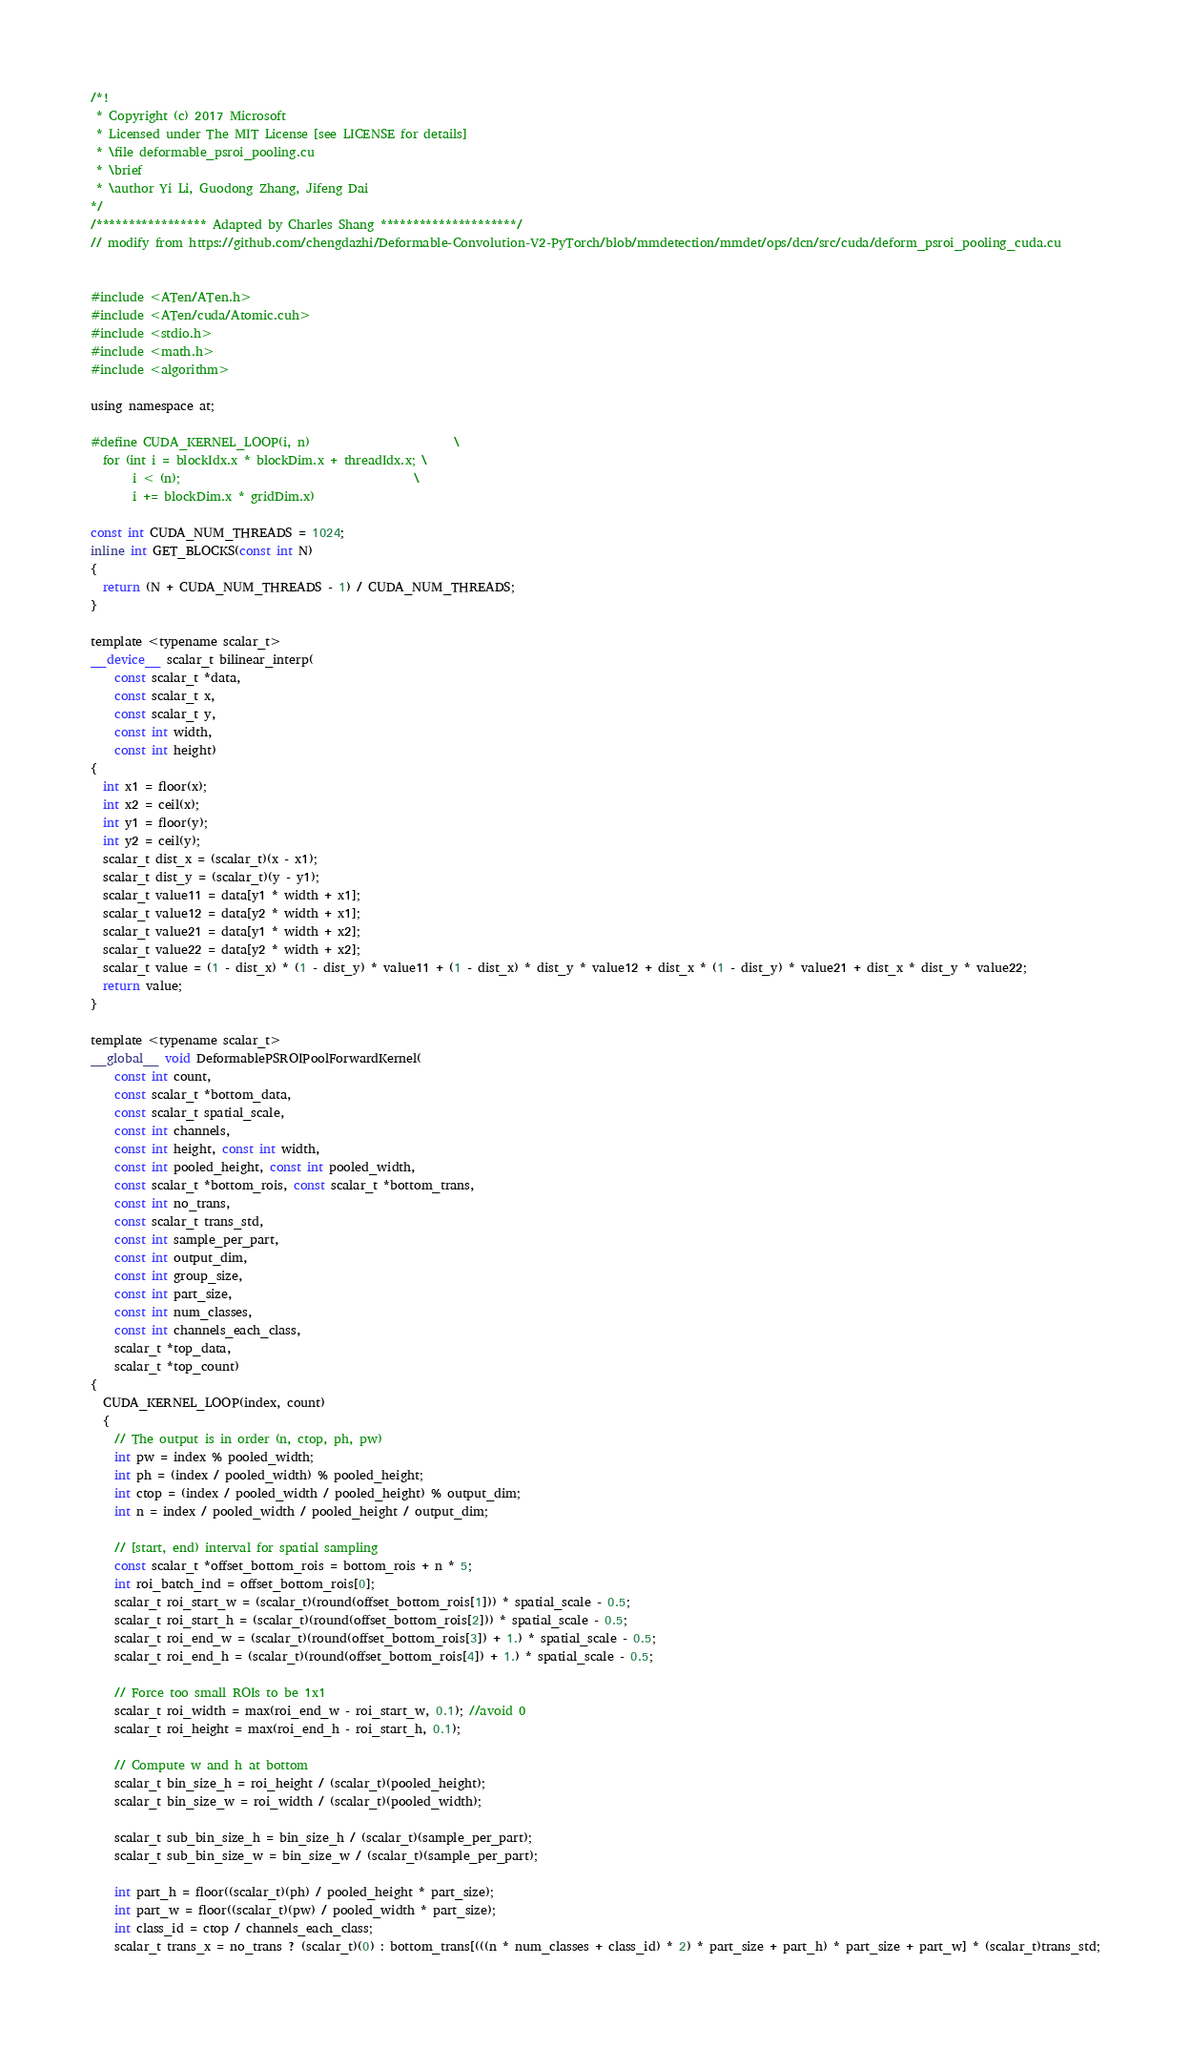Convert code to text. <code><loc_0><loc_0><loc_500><loc_500><_Cuda_>/*!
 * Copyright (c) 2017 Microsoft
 * Licensed under The MIT License [see LICENSE for details]
 * \file deformable_psroi_pooling.cu
 * \brief
 * \author Yi Li, Guodong Zhang, Jifeng Dai
*/
/***************** Adapted by Charles Shang *********************/
// modify from https://github.com/chengdazhi/Deformable-Convolution-V2-PyTorch/blob/mmdetection/mmdet/ops/dcn/src/cuda/deform_psroi_pooling_cuda.cu


#include <ATen/ATen.h>
#include <ATen/cuda/Atomic.cuh>
#include <stdio.h>
#include <math.h>
#include <algorithm>

using namespace at;

#define CUDA_KERNEL_LOOP(i, n)                        \
  for (int i = blockIdx.x * blockDim.x + threadIdx.x; \
       i < (n);                                       \
       i += blockDim.x * gridDim.x)

const int CUDA_NUM_THREADS = 1024;
inline int GET_BLOCKS(const int N)
{
  return (N + CUDA_NUM_THREADS - 1) / CUDA_NUM_THREADS;
}

template <typename scalar_t>
__device__ scalar_t bilinear_interp(
    const scalar_t *data,
    const scalar_t x,
    const scalar_t y,
    const int width,
    const int height)
{
  int x1 = floor(x);
  int x2 = ceil(x);
  int y1 = floor(y);
  int y2 = ceil(y);
  scalar_t dist_x = (scalar_t)(x - x1);
  scalar_t dist_y = (scalar_t)(y - y1);
  scalar_t value11 = data[y1 * width + x1];
  scalar_t value12 = data[y2 * width + x1];
  scalar_t value21 = data[y1 * width + x2];
  scalar_t value22 = data[y2 * width + x2];
  scalar_t value = (1 - dist_x) * (1 - dist_y) * value11 + (1 - dist_x) * dist_y * value12 + dist_x * (1 - dist_y) * value21 + dist_x * dist_y * value22;
  return value;
}

template <typename scalar_t>
__global__ void DeformablePSROIPoolForwardKernel(
    const int count,
    const scalar_t *bottom_data,
    const scalar_t spatial_scale,
    const int channels,
    const int height, const int width,
    const int pooled_height, const int pooled_width,
    const scalar_t *bottom_rois, const scalar_t *bottom_trans,
    const int no_trans,
    const scalar_t trans_std,
    const int sample_per_part,
    const int output_dim,
    const int group_size,
    const int part_size,
    const int num_classes,
    const int channels_each_class,
    scalar_t *top_data,
    scalar_t *top_count)
{
  CUDA_KERNEL_LOOP(index, count)
  {
    // The output is in order (n, ctop, ph, pw)
    int pw = index % pooled_width;
    int ph = (index / pooled_width) % pooled_height;
    int ctop = (index / pooled_width / pooled_height) % output_dim;
    int n = index / pooled_width / pooled_height / output_dim;

    // [start, end) interval for spatial sampling
    const scalar_t *offset_bottom_rois = bottom_rois + n * 5;
    int roi_batch_ind = offset_bottom_rois[0];
    scalar_t roi_start_w = (scalar_t)(round(offset_bottom_rois[1])) * spatial_scale - 0.5;
    scalar_t roi_start_h = (scalar_t)(round(offset_bottom_rois[2])) * spatial_scale - 0.5;
    scalar_t roi_end_w = (scalar_t)(round(offset_bottom_rois[3]) + 1.) * spatial_scale - 0.5;
    scalar_t roi_end_h = (scalar_t)(round(offset_bottom_rois[4]) + 1.) * spatial_scale - 0.5;

    // Force too small ROIs to be 1x1
    scalar_t roi_width = max(roi_end_w - roi_start_w, 0.1); //avoid 0
    scalar_t roi_height = max(roi_end_h - roi_start_h, 0.1);

    // Compute w and h at bottom
    scalar_t bin_size_h = roi_height / (scalar_t)(pooled_height);
    scalar_t bin_size_w = roi_width / (scalar_t)(pooled_width);

    scalar_t sub_bin_size_h = bin_size_h / (scalar_t)(sample_per_part);
    scalar_t sub_bin_size_w = bin_size_w / (scalar_t)(sample_per_part);

    int part_h = floor((scalar_t)(ph) / pooled_height * part_size);
    int part_w = floor((scalar_t)(pw) / pooled_width * part_size);
    int class_id = ctop / channels_each_class;
    scalar_t trans_x = no_trans ? (scalar_t)(0) : bottom_trans[(((n * num_classes + class_id) * 2) * part_size + part_h) * part_size + part_w] * (scalar_t)trans_std;</code> 